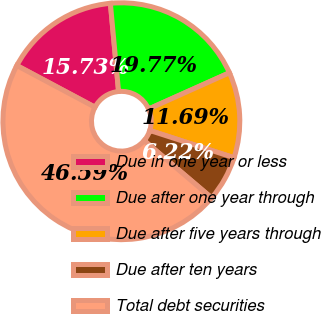<chart> <loc_0><loc_0><loc_500><loc_500><pie_chart><fcel>Due in one year or less<fcel>Due after one year through<fcel>Due after five years through<fcel>Due after ten years<fcel>Total debt securities<nl><fcel>15.73%<fcel>19.77%<fcel>11.69%<fcel>6.22%<fcel>46.59%<nl></chart> 